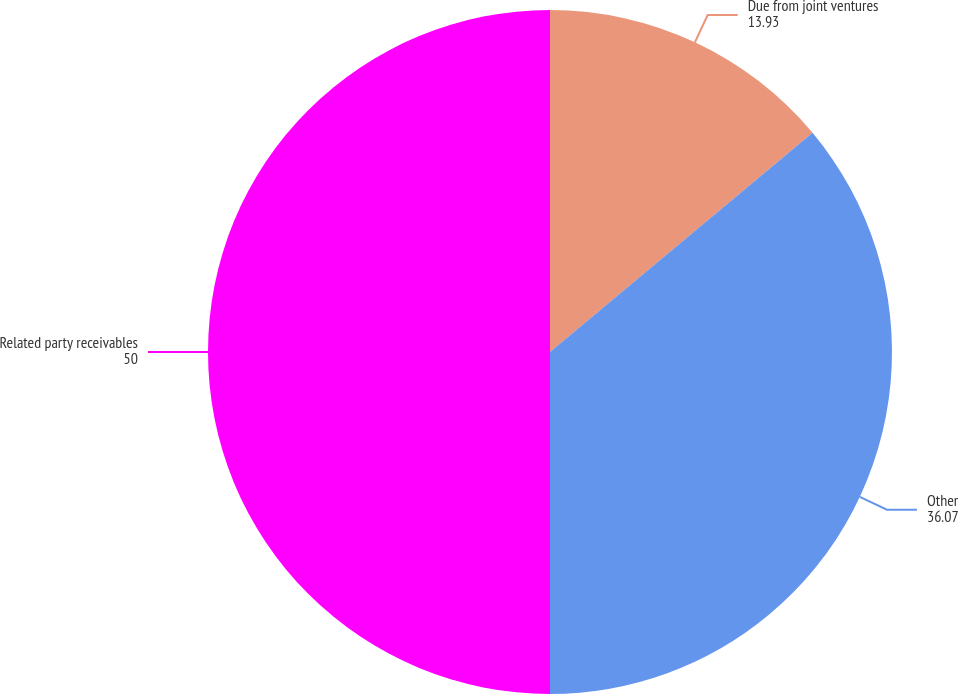Convert chart to OTSL. <chart><loc_0><loc_0><loc_500><loc_500><pie_chart><fcel>Due from joint ventures<fcel>Other<fcel>Related party receivables<nl><fcel>13.93%<fcel>36.07%<fcel>50.0%<nl></chart> 